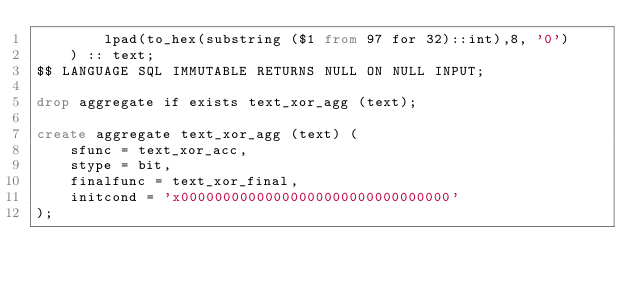Convert code to text. <code><loc_0><loc_0><loc_500><loc_500><_SQL_>        lpad(to_hex(substring ($1 from 97 for 32)::int),8, '0')
    ) :: text;
$$ LANGUAGE SQL IMMUTABLE RETURNS NULL ON NULL INPUT;

drop aggregate if exists text_xor_agg (text);

create aggregate text_xor_agg (text) (
    sfunc = text_xor_acc,
    stype = bit,
    finalfunc = text_xor_final,
    initcond = 'x00000000000000000000000000000000'
);
</code> 